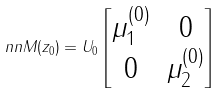Convert formula to latex. <formula><loc_0><loc_0><loc_500><loc_500>\ n n M ( z _ { 0 } ) = U _ { 0 } \begin{bmatrix} \mu _ { 1 } ^ { ( 0 ) } & 0 \\ 0 & \mu _ { 2 } ^ { ( 0 ) } \end{bmatrix}</formula> 